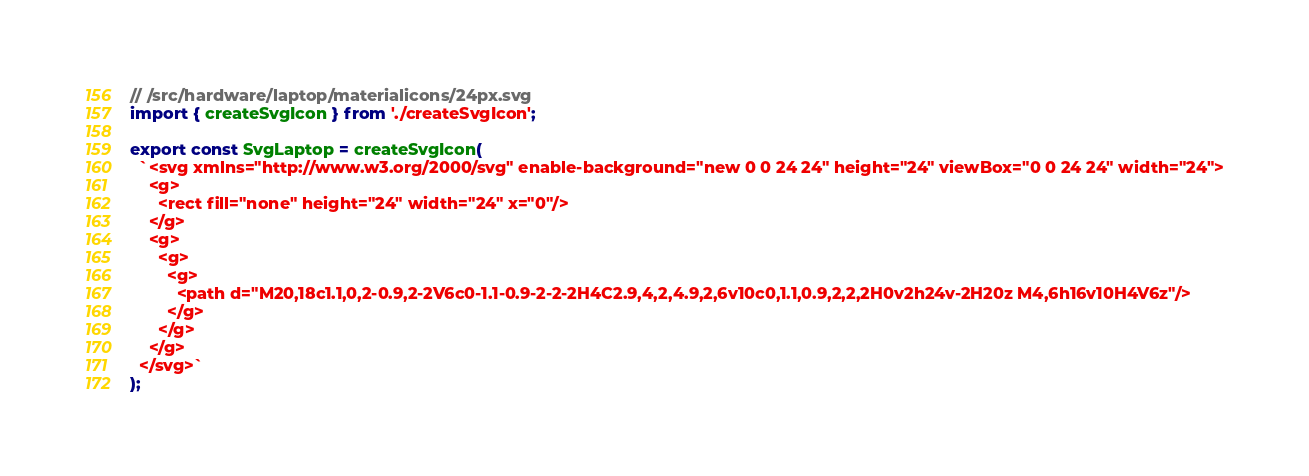Convert code to text. <code><loc_0><loc_0><loc_500><loc_500><_TypeScript_>// /src/hardware/laptop/materialicons/24px.svg
import { createSvgIcon } from './createSvgIcon';

export const SvgLaptop = createSvgIcon(
  `<svg xmlns="http://www.w3.org/2000/svg" enable-background="new 0 0 24 24" height="24" viewBox="0 0 24 24" width="24">
    <g>
      <rect fill="none" height="24" width="24" x="0"/>
    </g>
    <g>
      <g>
        <g>
          <path d="M20,18c1.1,0,2-0.9,2-2V6c0-1.1-0.9-2-2-2H4C2.9,4,2,4.9,2,6v10c0,1.1,0.9,2,2,2H0v2h24v-2H20z M4,6h16v10H4V6z"/>
        </g>
      </g>
    </g>
  </svg>`
);

</code> 